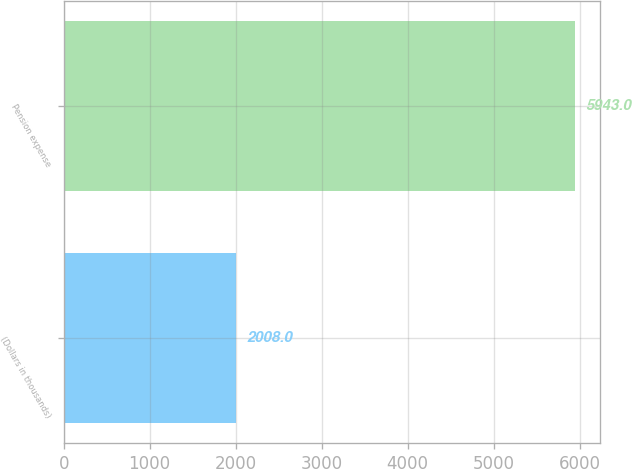Convert chart. <chart><loc_0><loc_0><loc_500><loc_500><bar_chart><fcel>(Dollars in thousands)<fcel>Pension expense<nl><fcel>2008<fcel>5943<nl></chart> 